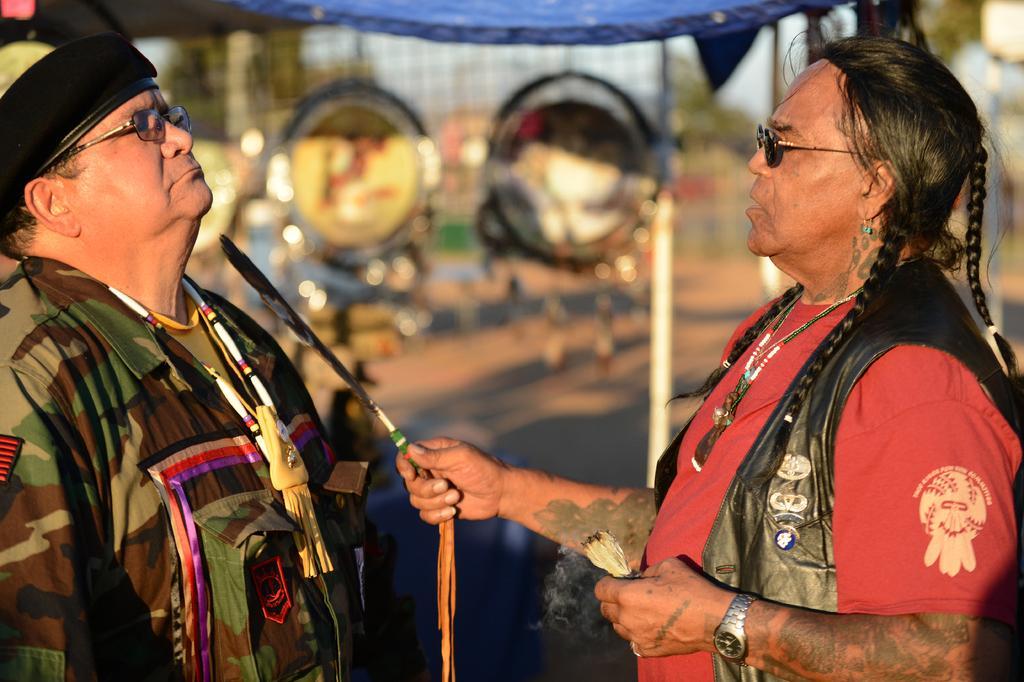Please provide a concise description of this image. In this picture I can see 2 men who are standing in front and I see that, the man on the right is holding a feather and a thing in his hands and the man on the left is wearing a cap. I see that it is blurred in the background. On the top of this picture I see the blue color thing. 